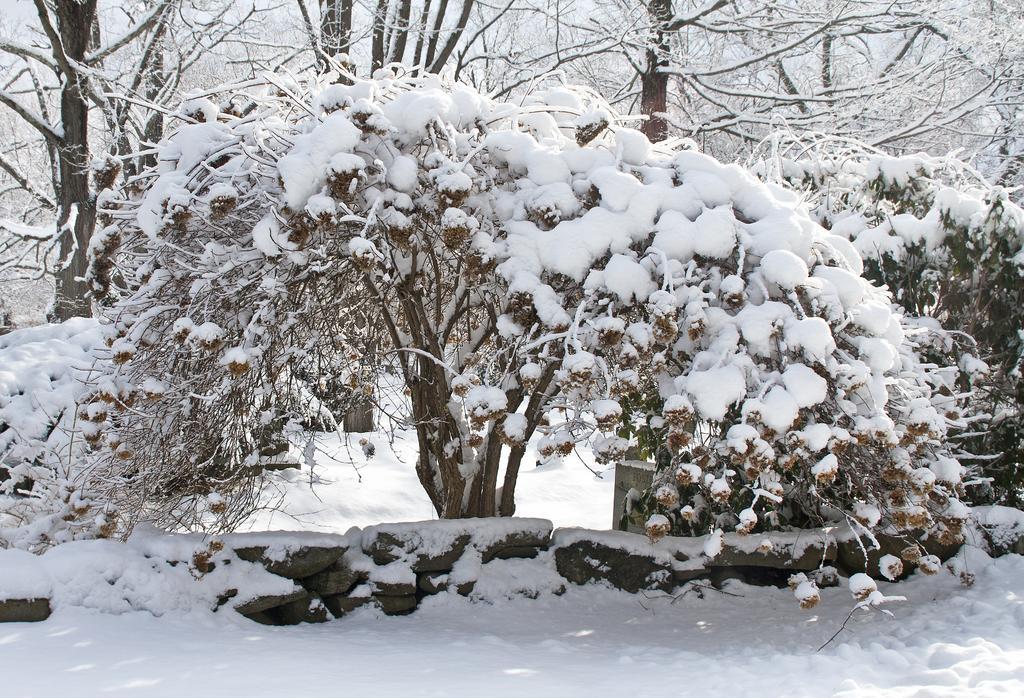Please provide a concise description of this image. There are plants on which, there is snow near the wall on which, there is snow near the snow surface. In the background, there are trees and plants on which, there is snow and there is sky. 